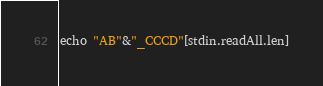<code> <loc_0><loc_0><loc_500><loc_500><_Nim_>echo "AB"&"_CCCD"[stdin.readAll.len]</code> 